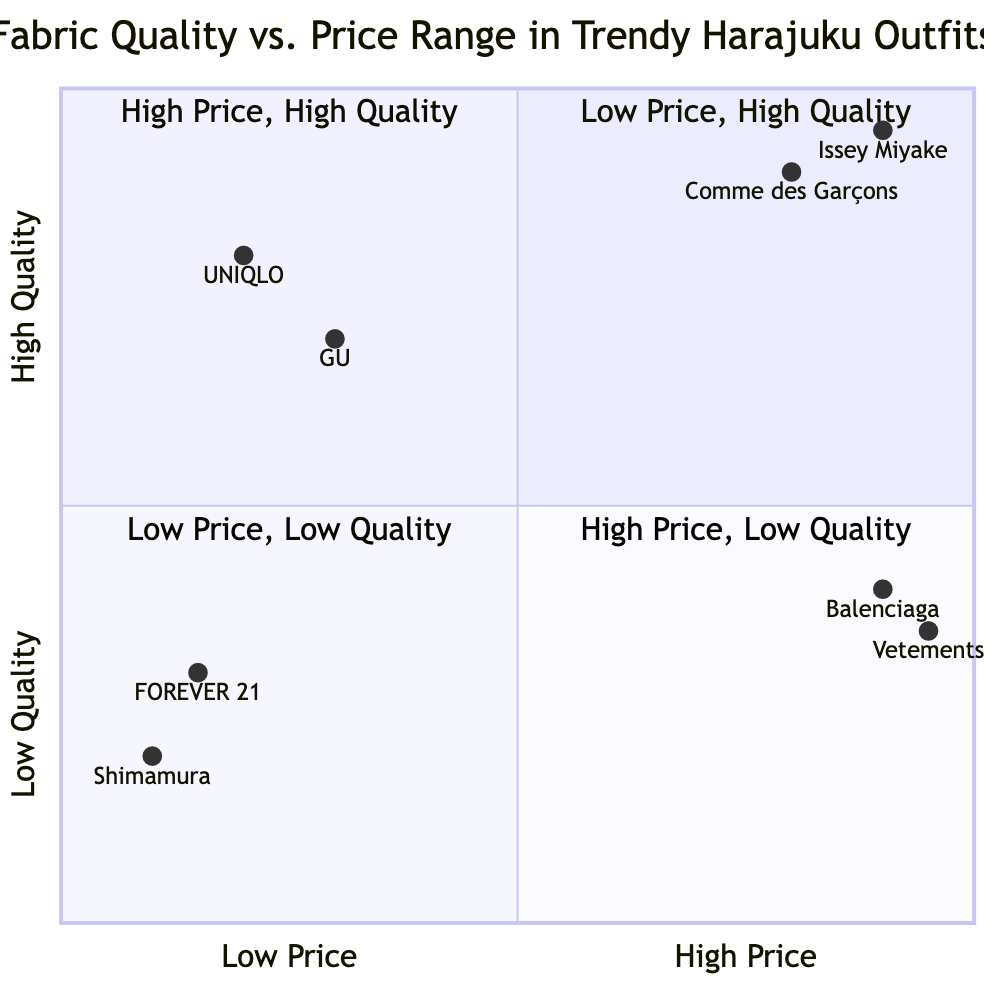What is the price range for GU? GU is located in the "Low Price, High Quality" quadrant, and according to the data, its price range is listed as "$20-$40."
Answer: $20-$40 Which brand is located in the "High Price, Low Quality" quadrant? The "High Price, Low Quality" quadrant contains the brands Balenciaga and Vetements. Selecting either of them as an answer would be correct. For this case, we can use Balenciaga as the example brand provided.
Answer: Balenciaga How many brands are in the "Low Price, Low Quality" quadrant? The "Low Price, Low Quality" quadrant includes two brands: Shimamura and FOREVER 21. Thus, the total number of brands in this quadrant is 2.
Answer: 2 What fabric is used by Issey Miyake? Issey Miyake is located in the "High Price, High Quality" quadrant, and its listed fabric is "Silk Blend."
Answer: Silk Blend Which quadrant has the highest quality fabrics? The "High Price, High Quality" quadrant is dedicated to premium quality fabrics offered at a higher cost, thereby representing the highest quality fabrics among the quadrants.
Answer: High Price, High Quality Is there a brand that offers low price but high quality fabrics? Yes, both GU and UNIQLO are brands located in the "Low Price, High Quality" quadrant, indicating that they provide affordable fabrics without compromising on quality.
Answer: Yes What are the key features of the fabric used by UNIQLO? UNIQLO's fabric, "Airism", is described with key features such as "Breathable" and "Moisture-Wicking," which are highlighted in the dataset as its prominent characteristics.
Answer: Breathable, Moisture-Wicking Which brand has the highest price range listed? The brand "Vetements" has the highest price range listed, at "$500-$1000," indicating that it is positioned among the expensive labels despite the quality considerations.
Answer: Vetements What is the fabric used by Shimamura? The fabric utilized by Shimamura, which is located in the "Low Price, Low Quality" quadrant, is identified as "Polyester" in the provided dataset.
Answer: Polyester 